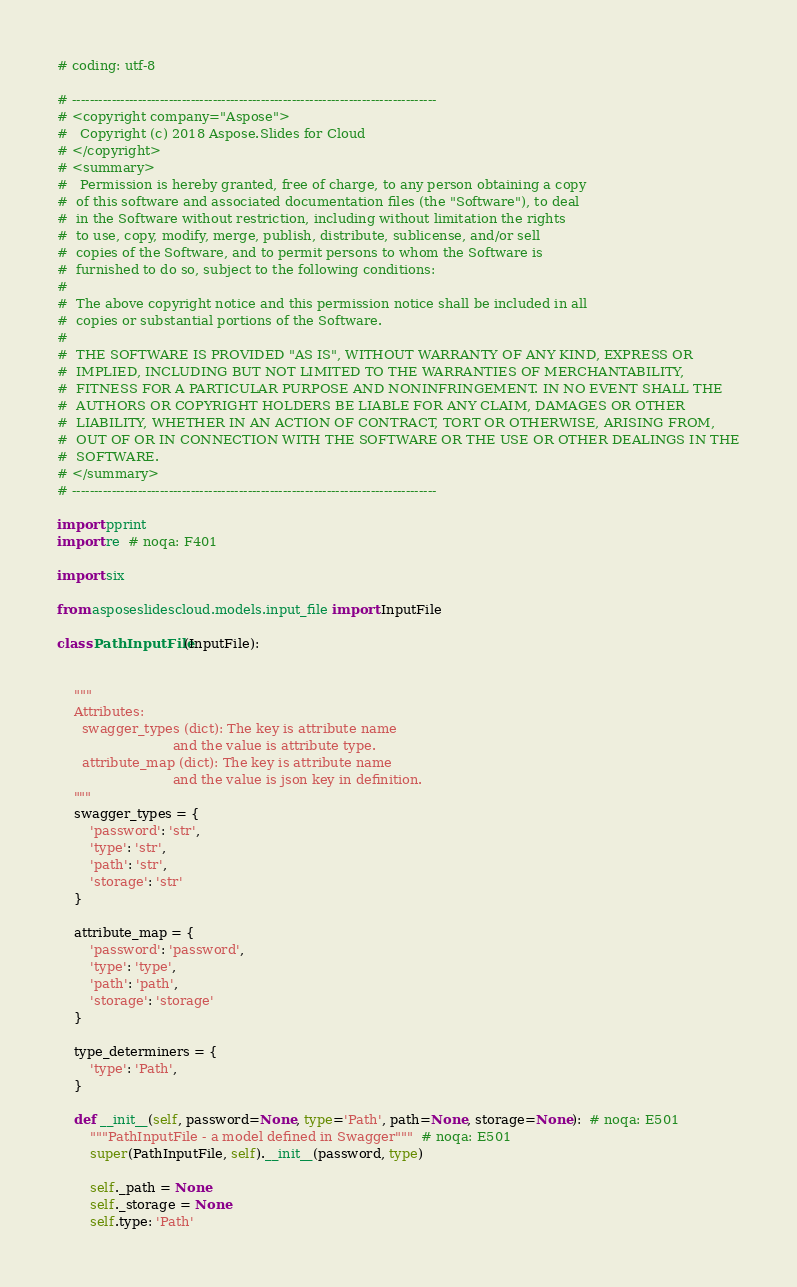<code> <loc_0><loc_0><loc_500><loc_500><_Python_># coding: utf-8

# -----------------------------------------------------------------------------------
# <copyright company="Aspose">
#   Copyright (c) 2018 Aspose.Slides for Cloud
# </copyright>
# <summary>
#   Permission is hereby granted, free of charge, to any person obtaining a copy
#  of this software and associated documentation files (the "Software"), to deal
#  in the Software without restriction, including without limitation the rights
#  to use, copy, modify, merge, publish, distribute, sublicense, and/or sell
#  copies of the Software, and to permit persons to whom the Software is
#  furnished to do so, subject to the following conditions:
#
#  The above copyright notice and this permission notice shall be included in all
#  copies or substantial portions of the Software.
#
#  THE SOFTWARE IS PROVIDED "AS IS", WITHOUT WARRANTY OF ANY KIND, EXPRESS OR
#  IMPLIED, INCLUDING BUT NOT LIMITED TO THE WARRANTIES OF MERCHANTABILITY,
#  FITNESS FOR A PARTICULAR PURPOSE AND NONINFRINGEMENT. IN NO EVENT SHALL THE
#  AUTHORS OR COPYRIGHT HOLDERS BE LIABLE FOR ANY CLAIM, DAMAGES OR OTHER
#  LIABILITY, WHETHER IN AN ACTION OF CONTRACT, TORT OR OTHERWISE, ARISING FROM,
#  OUT OF OR IN CONNECTION WITH THE SOFTWARE OR THE USE OR OTHER DEALINGS IN THE
#  SOFTWARE.
# </summary>
# -----------------------------------------------------------------------------------

import pprint
import re  # noqa: F401

import six

from asposeslidescloud.models.input_file import InputFile

class PathInputFile(InputFile):


    """
    Attributes:
      swagger_types (dict): The key is attribute name
                            and the value is attribute type.
      attribute_map (dict): The key is attribute name
                            and the value is json key in definition.
    """
    swagger_types = {
        'password': 'str',
        'type': 'str',
        'path': 'str',
        'storage': 'str'
    }

    attribute_map = {
        'password': 'password',
        'type': 'type',
        'path': 'path',
        'storage': 'storage'
    }

    type_determiners = {
        'type': 'Path',
    }

    def __init__(self, password=None, type='Path', path=None, storage=None):  # noqa: E501
        """PathInputFile - a model defined in Swagger"""  # noqa: E501
        super(PathInputFile, self).__init__(password, type)

        self._path = None
        self._storage = None
        self.type: 'Path'
</code> 